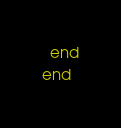Convert code to text. <code><loc_0><loc_0><loc_500><loc_500><_Crystal_>  end
end
</code> 